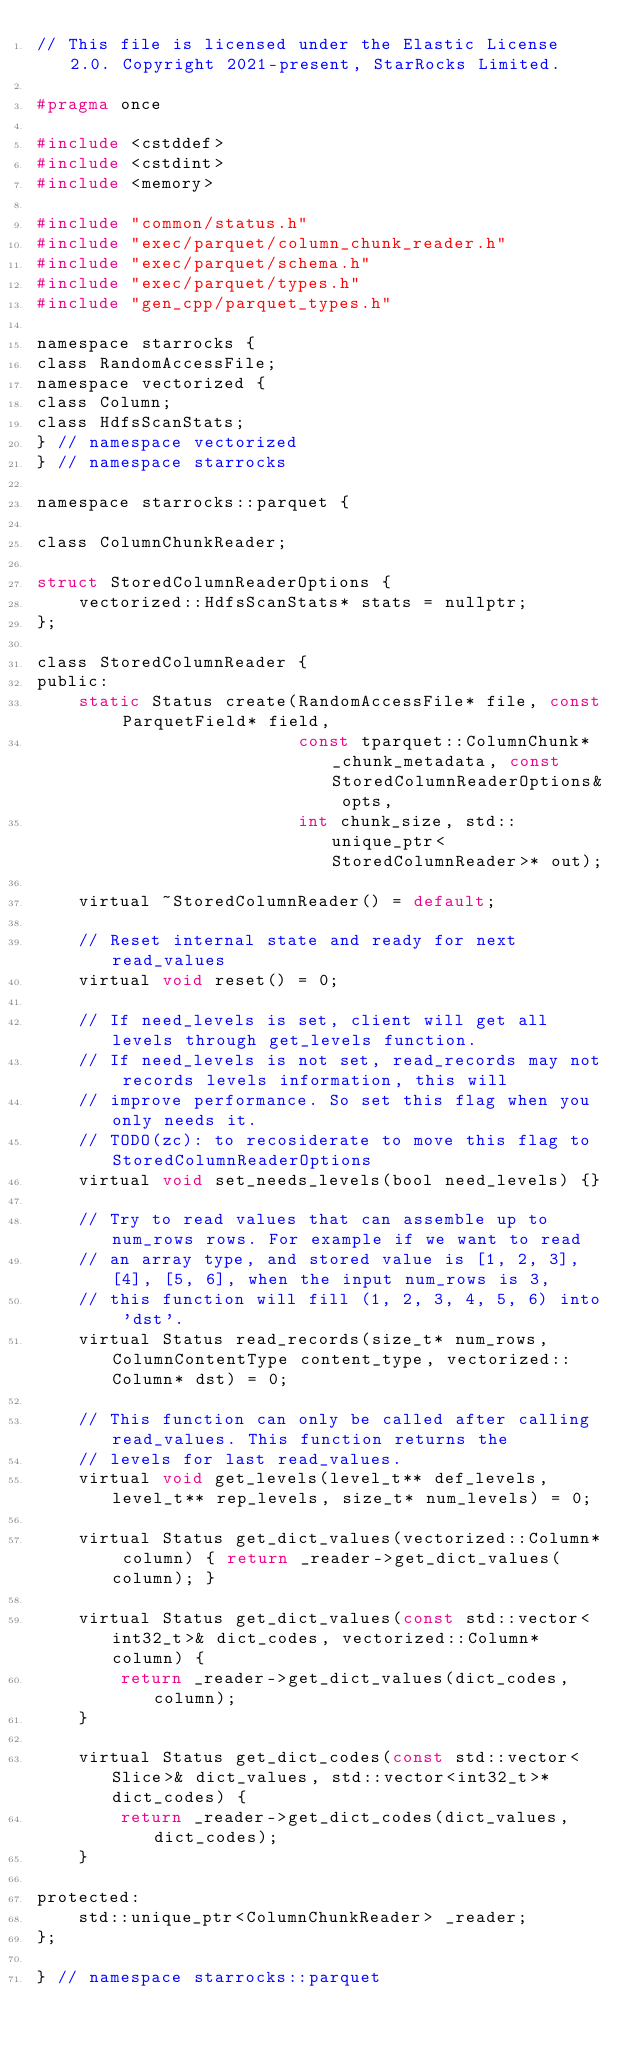Convert code to text. <code><loc_0><loc_0><loc_500><loc_500><_C_>// This file is licensed under the Elastic License 2.0. Copyright 2021-present, StarRocks Limited.

#pragma once

#include <cstddef>
#include <cstdint>
#include <memory>

#include "common/status.h"
#include "exec/parquet/column_chunk_reader.h"
#include "exec/parquet/schema.h"
#include "exec/parquet/types.h"
#include "gen_cpp/parquet_types.h"

namespace starrocks {
class RandomAccessFile;
namespace vectorized {
class Column;
class HdfsScanStats;
} // namespace vectorized
} // namespace starrocks

namespace starrocks::parquet {

class ColumnChunkReader;

struct StoredColumnReaderOptions {
    vectorized::HdfsScanStats* stats = nullptr;
};

class StoredColumnReader {
public:
    static Status create(RandomAccessFile* file, const ParquetField* field,
                         const tparquet::ColumnChunk* _chunk_metadata, const StoredColumnReaderOptions& opts,
                         int chunk_size, std::unique_ptr<StoredColumnReader>* out);

    virtual ~StoredColumnReader() = default;

    // Reset internal state and ready for next read_values
    virtual void reset() = 0;

    // If need_levels is set, client will get all levels through get_levels function.
    // If need_levels is not set, read_records may not records levels information, this will
    // improve performance. So set this flag when you only needs it.
    // TODO(zc): to recosiderate to move this flag to StoredColumnReaderOptions
    virtual void set_needs_levels(bool need_levels) {}

    // Try to read values that can assemble up to num_rows rows. For example if we want to read
    // an array type, and stored value is [1, 2, 3], [4], [5, 6], when the input num_rows is 3,
    // this function will fill (1, 2, 3, 4, 5, 6) into 'dst'.
    virtual Status read_records(size_t* num_rows, ColumnContentType content_type, vectorized::Column* dst) = 0;

    // This function can only be called after calling read_values. This function returns the
    // levels for last read_values.
    virtual void get_levels(level_t** def_levels, level_t** rep_levels, size_t* num_levels) = 0;

    virtual Status get_dict_values(vectorized::Column* column) { return _reader->get_dict_values(column); }

    virtual Status get_dict_values(const std::vector<int32_t>& dict_codes, vectorized::Column* column) {
        return _reader->get_dict_values(dict_codes, column);
    }

    virtual Status get_dict_codes(const std::vector<Slice>& dict_values, std::vector<int32_t>* dict_codes) {
        return _reader->get_dict_codes(dict_values, dict_codes);
    }

protected:
    std::unique_ptr<ColumnChunkReader> _reader;
};

} // namespace starrocks::parquet
</code> 